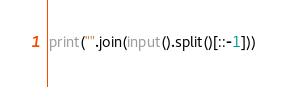Convert code to text. <code><loc_0><loc_0><loc_500><loc_500><_Python_>print("".join(input().split()[::-1]))</code> 